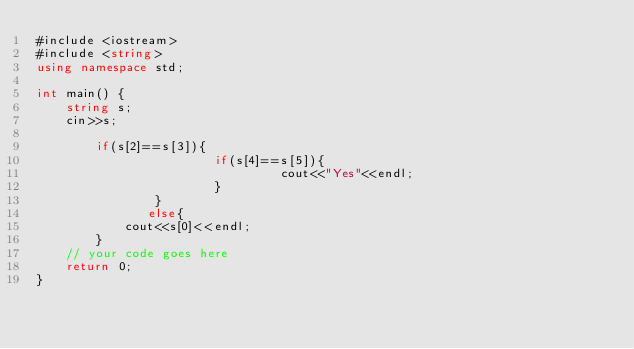<code> <loc_0><loc_0><loc_500><loc_500><_C#_>#include <iostream>
#include <string>
using namespace std;

int main() {
	string s;
	cin>>s;
	
		if(s[2]==s[3]){
                        if(s[4]==s[5]){
                                 cout<<"Yes"<<endl;
                        }
                }
               else{
	        cout<<s[0]<<endl;
        }
	// your code goes here
	return 0;
}</code> 